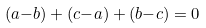Convert formula to latex. <formula><loc_0><loc_0><loc_500><loc_500>( a { - } b ) + ( c { - } a ) + ( b { - } c ) & = 0</formula> 